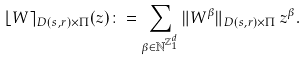Convert formula to latex. <formula><loc_0><loc_0><loc_500><loc_500>\lfloor W \rceil _ { D ( s , r ) \times \Pi } ( z ) \colon = \sum _ { \beta \in \mathbb { N } ^ { { \mathbb { Z } _ { 1 } ^ { d } } } } \| W ^ { \beta } \| _ { D ( s , r ) \times \Pi } \, z ^ { \beta } .</formula> 